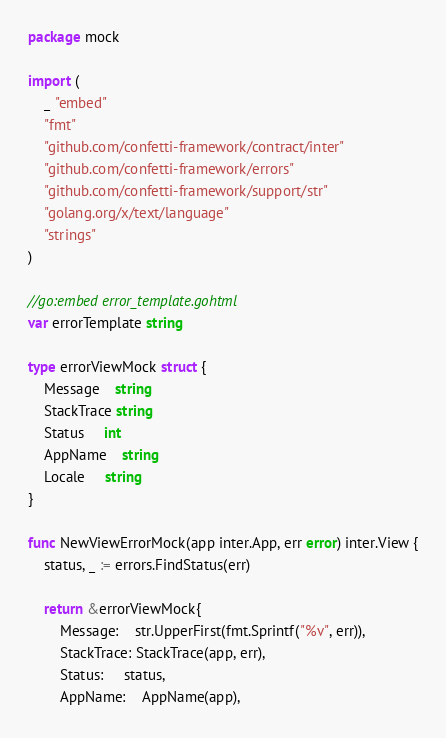<code> <loc_0><loc_0><loc_500><loc_500><_Go_>package mock

import (
	_ "embed"
	"fmt"
	"github.com/confetti-framework/contract/inter"
	"github.com/confetti-framework/errors"
	"github.com/confetti-framework/support/str"
	"golang.org/x/text/language"
	"strings"
)

//go:embed error_template.gohtml
var errorTemplate string

type errorViewMock struct {
	Message    string
	StackTrace string
	Status     int
	AppName    string
	Locale     string
}

func NewViewErrorMock(app inter.App, err error) inter.View {
	status, _ := errors.FindStatus(err)

	return &errorViewMock{
		Message:    str.UpperFirst(fmt.Sprintf("%v", err)),
		StackTrace: StackTrace(app, err),
		Status:     status,
		AppName:    AppName(app),</code> 